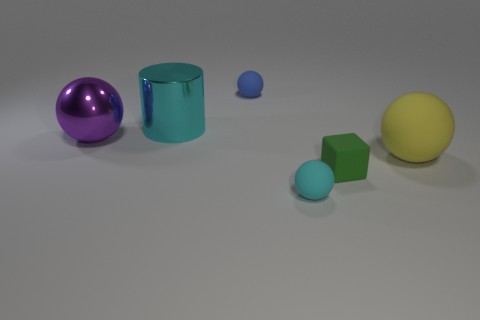Add 2 cyan rubber cylinders. How many objects exist? 8 Subtract all cubes. How many objects are left? 5 Subtract 0 red spheres. How many objects are left? 6 Subtract all big red metal blocks. Subtract all tiny rubber things. How many objects are left? 3 Add 3 tiny blue matte things. How many tiny blue matte things are left? 4 Add 2 tiny purple cubes. How many tiny purple cubes exist? 2 